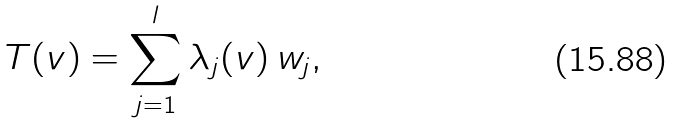Convert formula to latex. <formula><loc_0><loc_0><loc_500><loc_500>T ( v ) = \sum _ { j = 1 } ^ { l } \lambda _ { j } ( v ) \, w _ { j } ,</formula> 